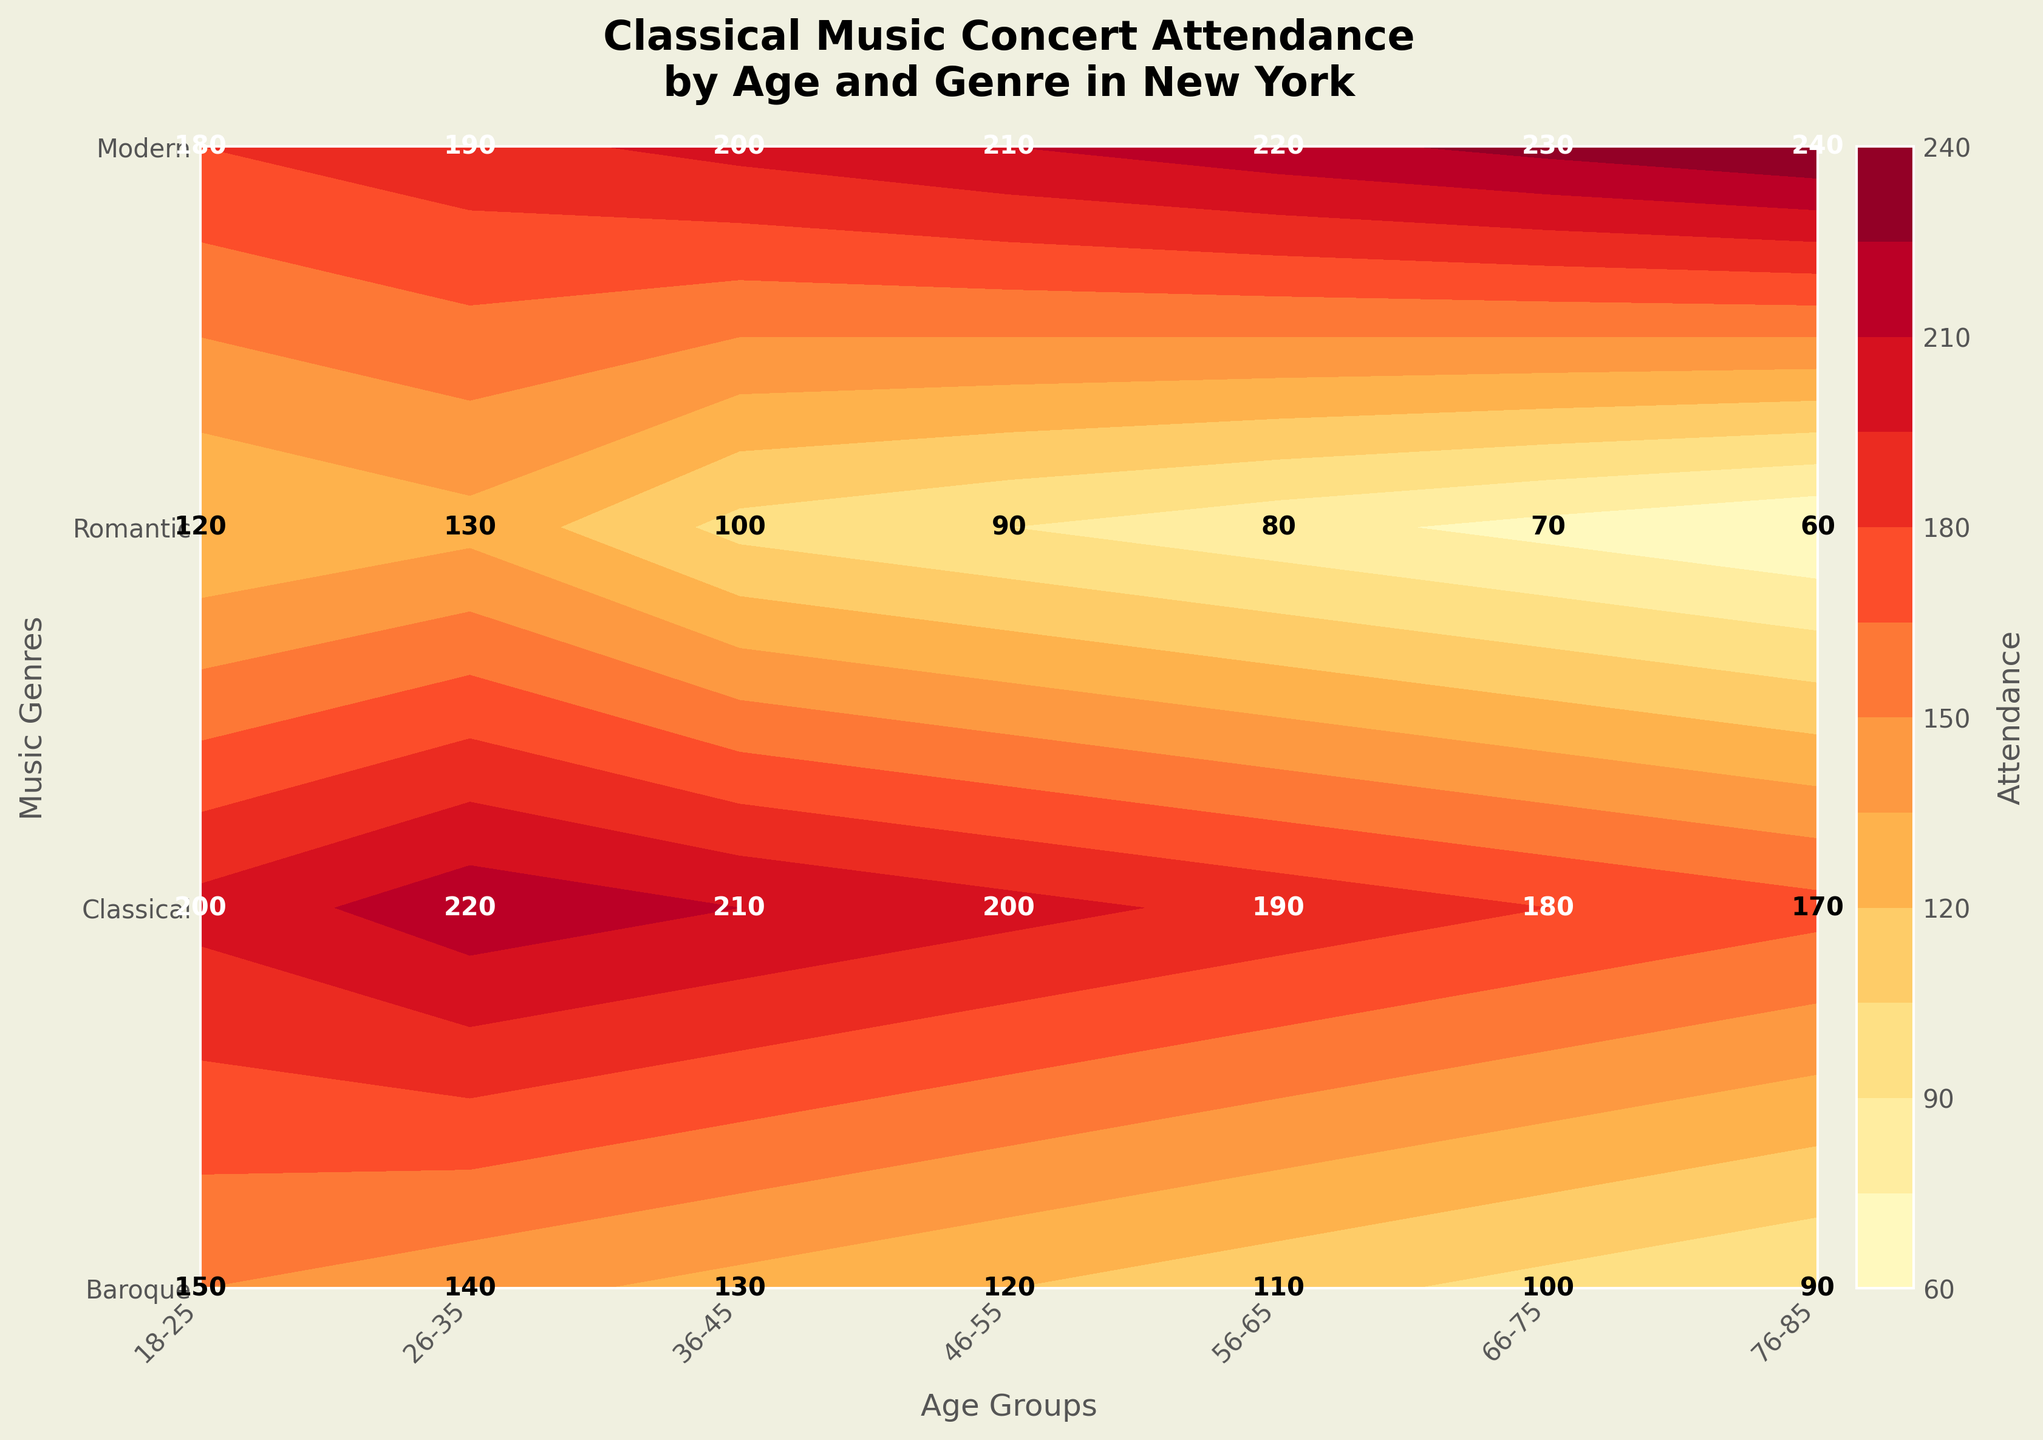What is the age group with the highest attendance for Romantic genre concerts? To find this, look at the value labels corresponding to the Romantic genre row and compare them across all age groups. The highest value is 240 for the 76-85 age group.
Answer: 76-85 What is the attendance for Classical genre concerts in the 26-35 age group? Find the value at the intersection of Classical row and 26-35 column. The labeled value is 220.
Answer: 220 Which genre has the least attendance overall? Sum the attendance values for each genre across all age groups. Baroque: 150+140+130+120+110+100+90 = 840, Classical: 200+220+210+200+190+180+170 = 1370, Romantic: 180+190+200+210+220+230+240 = 1470, Modern: 120+130+100+90+80+70+60 = 650. Modern has the least attendance.
Answer: Modern How many more people in the 56-65 age group attend Romantic concerts compared to Baroque concerts? Subtract the Romantic value from the Baroque value in the 56-65 age group: 220 - 110 = 110.
Answer: 110 Which age group shows a relatively balanced attendance across all genres? Look at the differences between attendance values within each age group. For 18-25: (200-150, 200-180, 200-120), 26-35: (220-140, 220-190, 220-130), etc. The age group 36-45 shows relatively balanced values (130, 210, 200, 100).
Answer: 36-45 What is the average attendance for Baroque concerts? Sum the attendance values for Baroque concerts (150+140+130+120+110+100+90 = 840) and divide by the number of age groups (7). 840 / 7 = 120.
Answer: 120 Between which two consecutive age groups is the largest increase in attendance for Romantic concerts observed? Compare the Romantic concert values for consecutive age groups: 18-25 to 26-35 (180 to 190), 26-35 to 36-45 (190 to 200), 36-45 to 46-55 (200 to 210), 46-55 to 56-65 (210 to 220), 56-65 to 66-75 (220 to 230), 66-75 to 76-85 (230 to 240). The largest increase is 10 between 66-75 and 76-85.
Answer: 66-75 to 76-85 